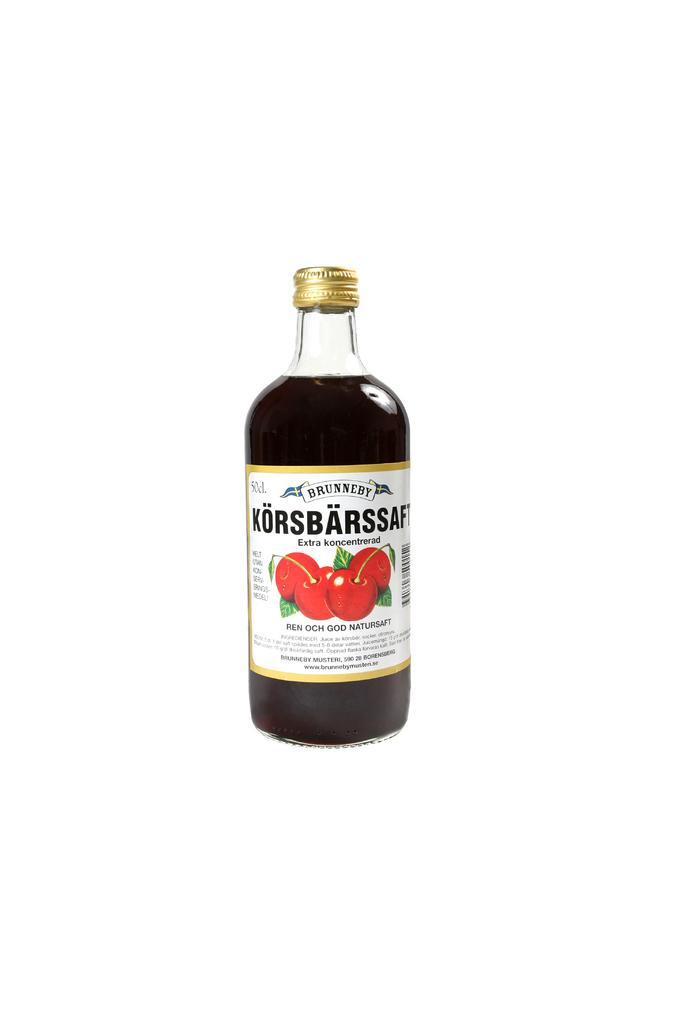What object can be seen in the image? There is a bottle in the image. What is on the bottle? The bottle has a label on it. What is the opinion of the bottle about the current political climate? The bottle is an inanimate object and cannot have an opinion about the current political climate. 